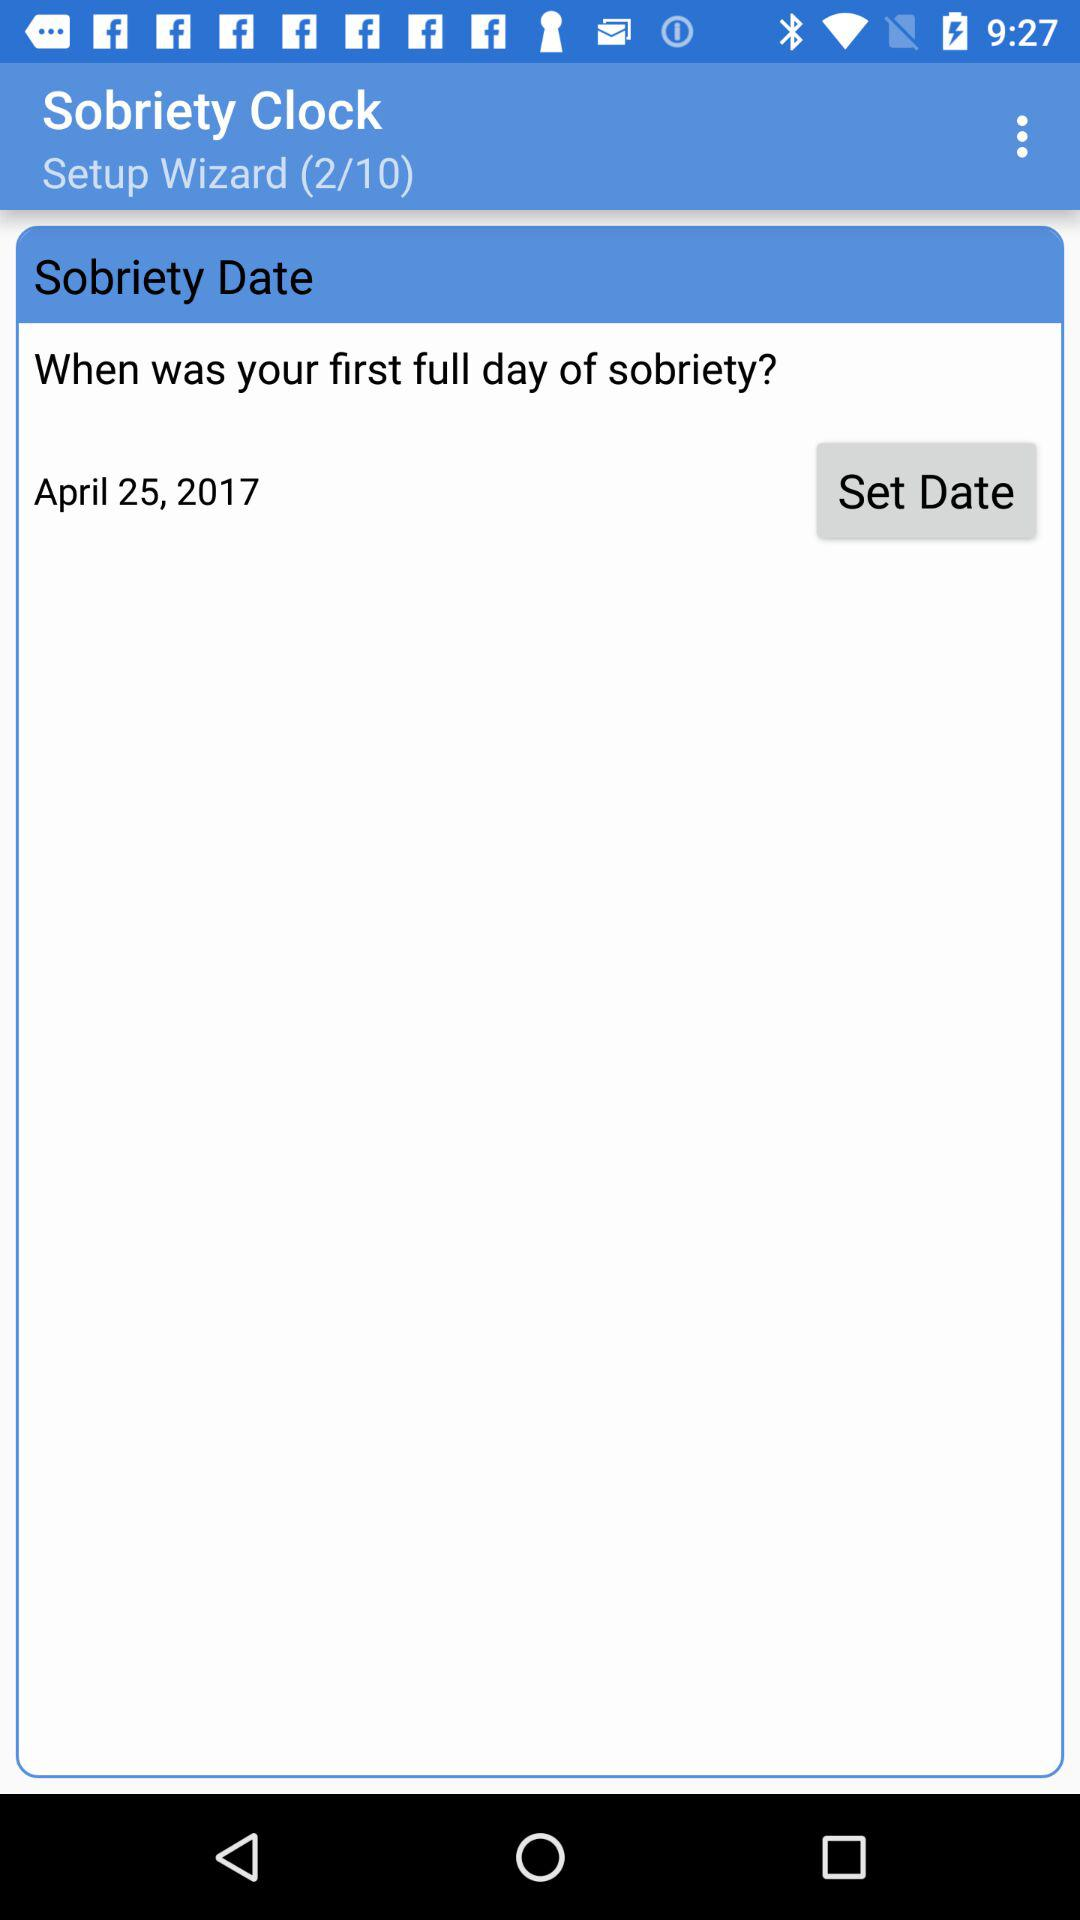What is the selected date for the first full day of sobriety? The selected date is April 25, 2017. 